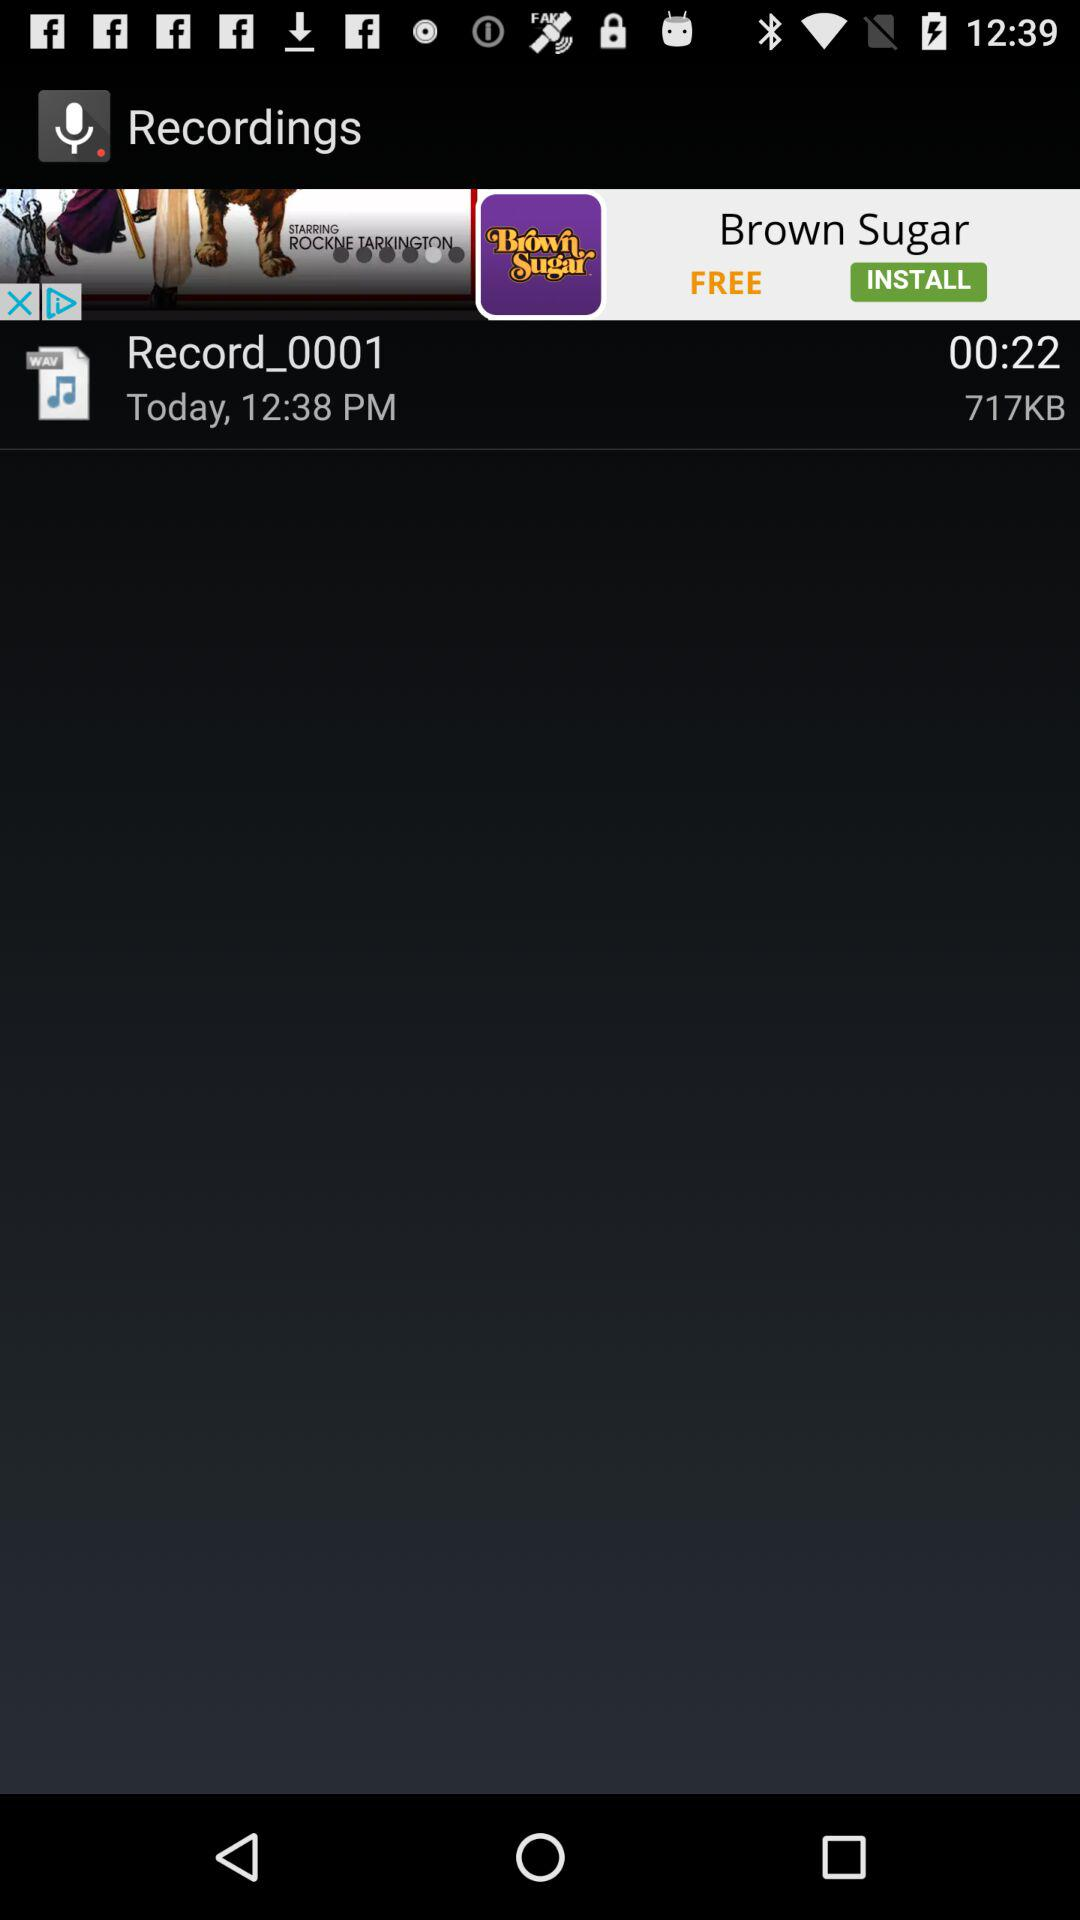What genre is "Record_0001"?
When the provided information is insufficient, respond with <no answer>. <no answer> 